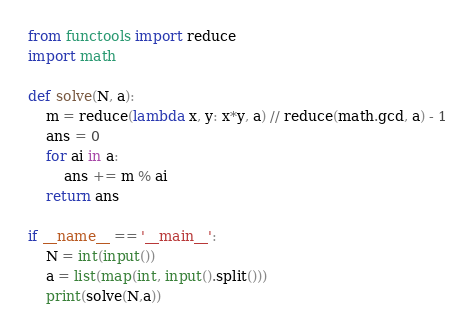<code> <loc_0><loc_0><loc_500><loc_500><_Python_>from functools import reduce
import math

def solve(N, a):
	m = reduce(lambda x, y: x*y, a) // reduce(math.gcd, a) - 1
	ans = 0
	for ai in a:
		ans += m % ai
	return ans

if __name__ == '__main__':
	N = int(input())
	a = list(map(int, input().split()))
	print(solve(N,a))</code> 